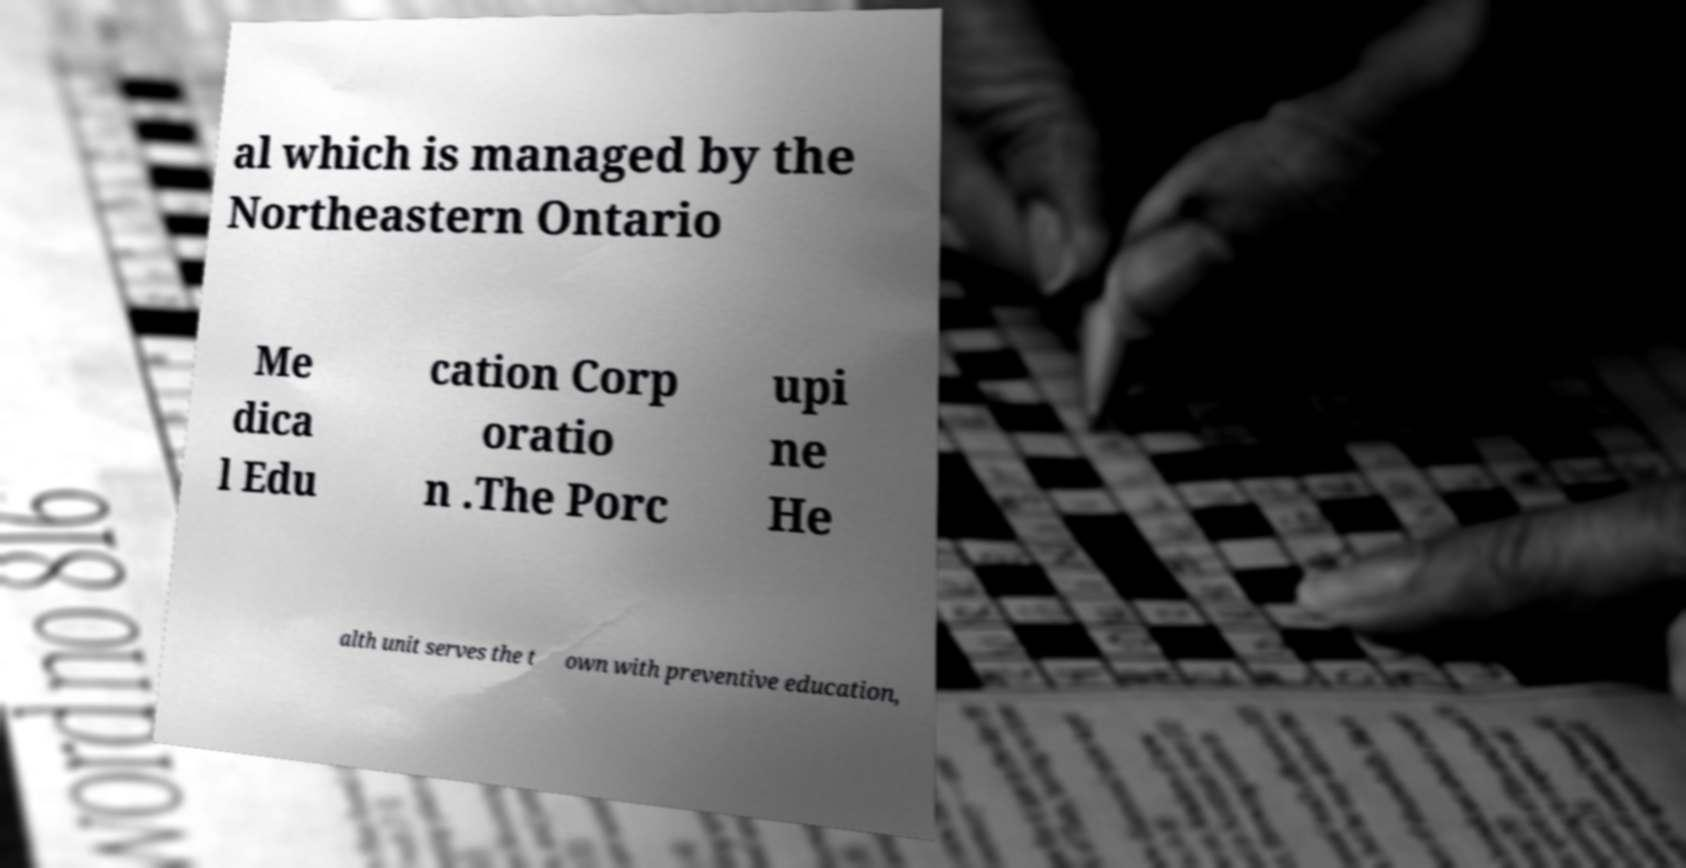Could you assist in decoding the text presented in this image and type it out clearly? al which is managed by the Northeastern Ontario Me dica l Edu cation Corp oratio n .The Porc upi ne He alth unit serves the t own with preventive education, 